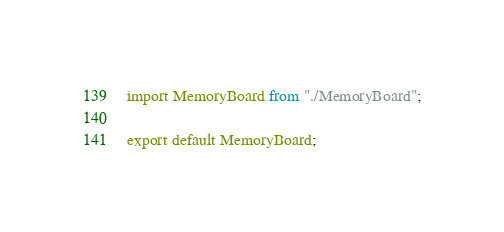Convert code to text. <code><loc_0><loc_0><loc_500><loc_500><_JavaScript_>import MemoryBoard from "./MemoryBoard";

export default MemoryBoard;
</code> 